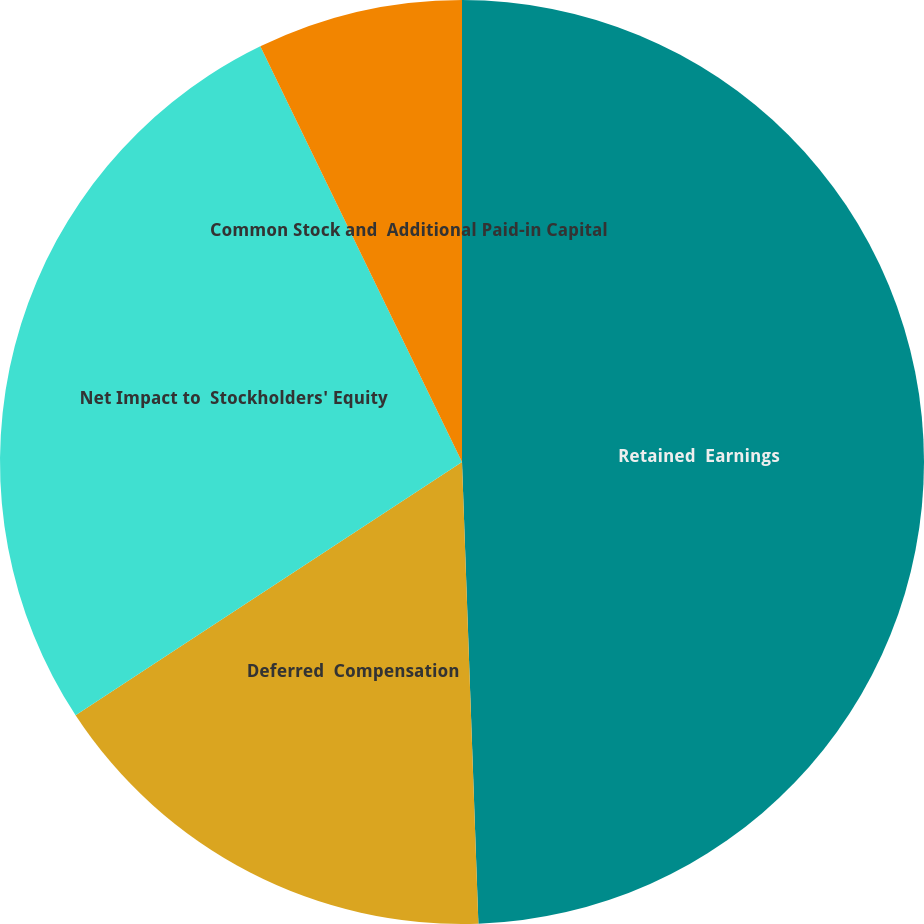Convert chart. <chart><loc_0><loc_0><loc_500><loc_500><pie_chart><fcel>Retained  Earnings<fcel>Deferred  Compensation<fcel>Net Impact to  Stockholders' Equity<fcel>Common Stock and  Additional Paid-in Capital<nl><fcel>49.43%<fcel>16.33%<fcel>27.04%<fcel>7.19%<nl></chart> 